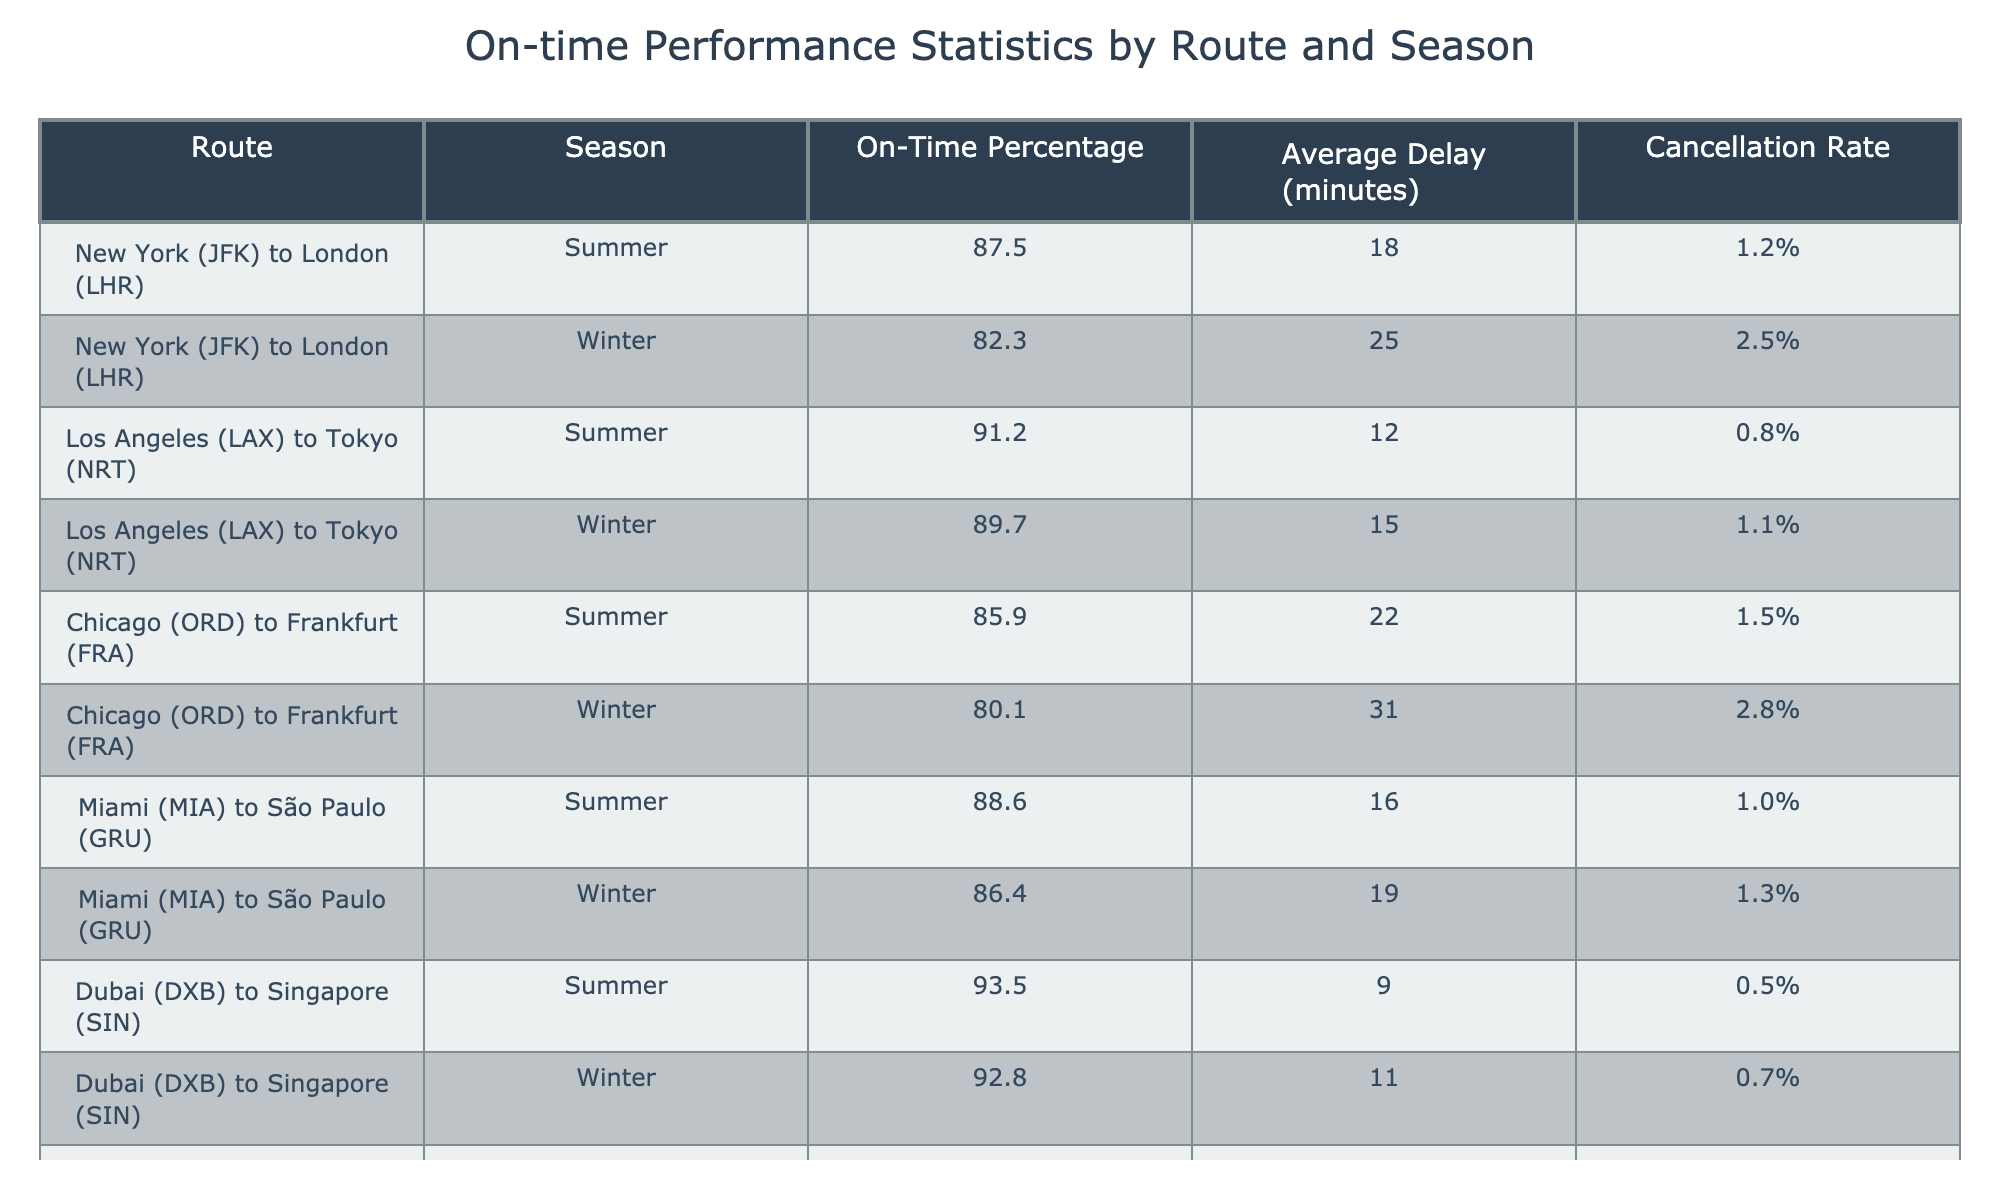What is the on-time percentage for the route from New York to London during the summer? According to the table, the on-time percentage for the route from New York (JFK) to London (LHR) in summer is listed as 87.5%.
Answer: 87.5% Which route has the highest cancellation rate in the winter season? The table shows that the Chicago (ORD) to Frankfurt (FRA) route has the highest cancellation rate in winter at 2.8%.
Answer: 2.8% What is the average delay for the route from Los Angeles to Tokyo across both seasons? To find the average delay, we sum the delays for both seasons: (12 + 15) = 27. There are 2 data points, so the average is 27 / 2 = 13.5 minutes.
Answer: 13.5 minutes Is the on-time percentage higher for the Miami to São Paulo route in summer or winter? The on-time percentage for Miami (MIA) to São Paulo (GRU) in summer is 88.6%, while in winter it is 86.4%. Since 88.6% > 86.4%, summer has a higher on-time percentage.
Answer: Yes, it's higher in summer What is the difference in average delay between the routes from Chicago to Frankfurt in summer and winter? The average delay for summer is 22 minutes, and for winter, it is 31 minutes. The difference is 31 - 22 = 9 minutes.
Answer: 9 minutes Is the on-time performance for the Hong Kong to Bangkok route better in summer or winter? In summer, the on-time performance is 94.2%, and in winter it is 93.6%. Since 94.2% is greater than 93.6%, the performance is better in summer.
Answer: Yes, it's better in summer What are the average on-time percentages for the Los Angeles to Tokyo route across both seasons? The on-time percentages are 91.2% in summer and 89.7% in winter. The average is (91.2 + 89.7) / 2 = 90.45%.
Answer: 90.45% Which route shows the least average delay in the summer? The table indicates that the Dubai (DXB) to Singapore (SIN) route has the least average delay in summer at 9 minutes.
Answer: 9 minutes Are the cancellation rates for the Miami to São Paulo route consistent across both seasons? The cancellation rates are 1.0% in summer and 1.3% in winter; they're not consistent since the values differ.
Answer: No, they are inconsistent What is the highest on-time percentage recorded in the table? By reviewing the on-time percentages, the highest recorded is 94.2% for the Hong Kong (HKG) to Bangkok (BKK) route in summer.
Answer: 94.2% Which route has an average delay equal to or below 15 minutes in winter? The Los Angeles (LAX) to Tokyo (NRT) route has an average delay of 15 minutes in winter, which is equal to the threshold.
Answer: Yes, Los Angeles to Tokyo meets this condition 